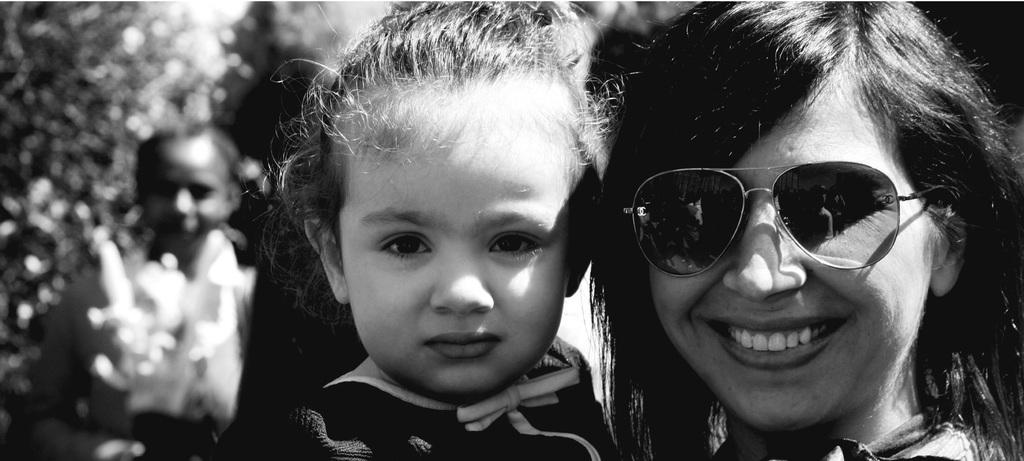What is the color scheme of the image? The image is black and white. What can be seen in the image? There is a group of people in the image. What is visible in the background of the image? There are trees visible in the background of the image. What type of spoon is being used by the people in the image? There is no spoon present in the image; it is a black and white image of a group of people with trees in the background. 